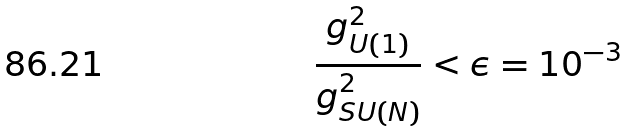<formula> <loc_0><loc_0><loc_500><loc_500>\frac { g ^ { 2 } _ { U ( 1 ) } } { g ^ { 2 } _ { S U ( N ) } } < \epsilon = 1 0 ^ { - 3 }</formula> 